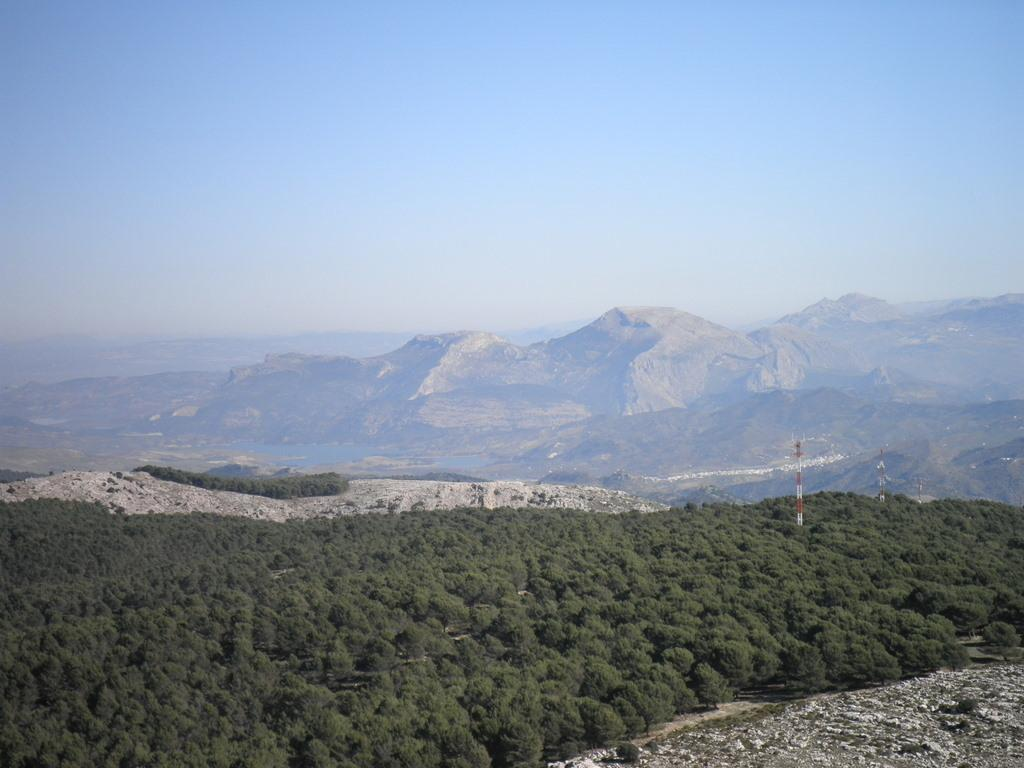What type of scenery is shown in the image? The image depicts a beautiful scenery. What can be observed in the image besides the scenery? There are many plants and huge mountains in the image. Where is the chair located in the image? There is no chair present in the image. What type of garden can be seen in the image? There is no garden present in the image; it features a beautiful scenery with plants and mountains. 